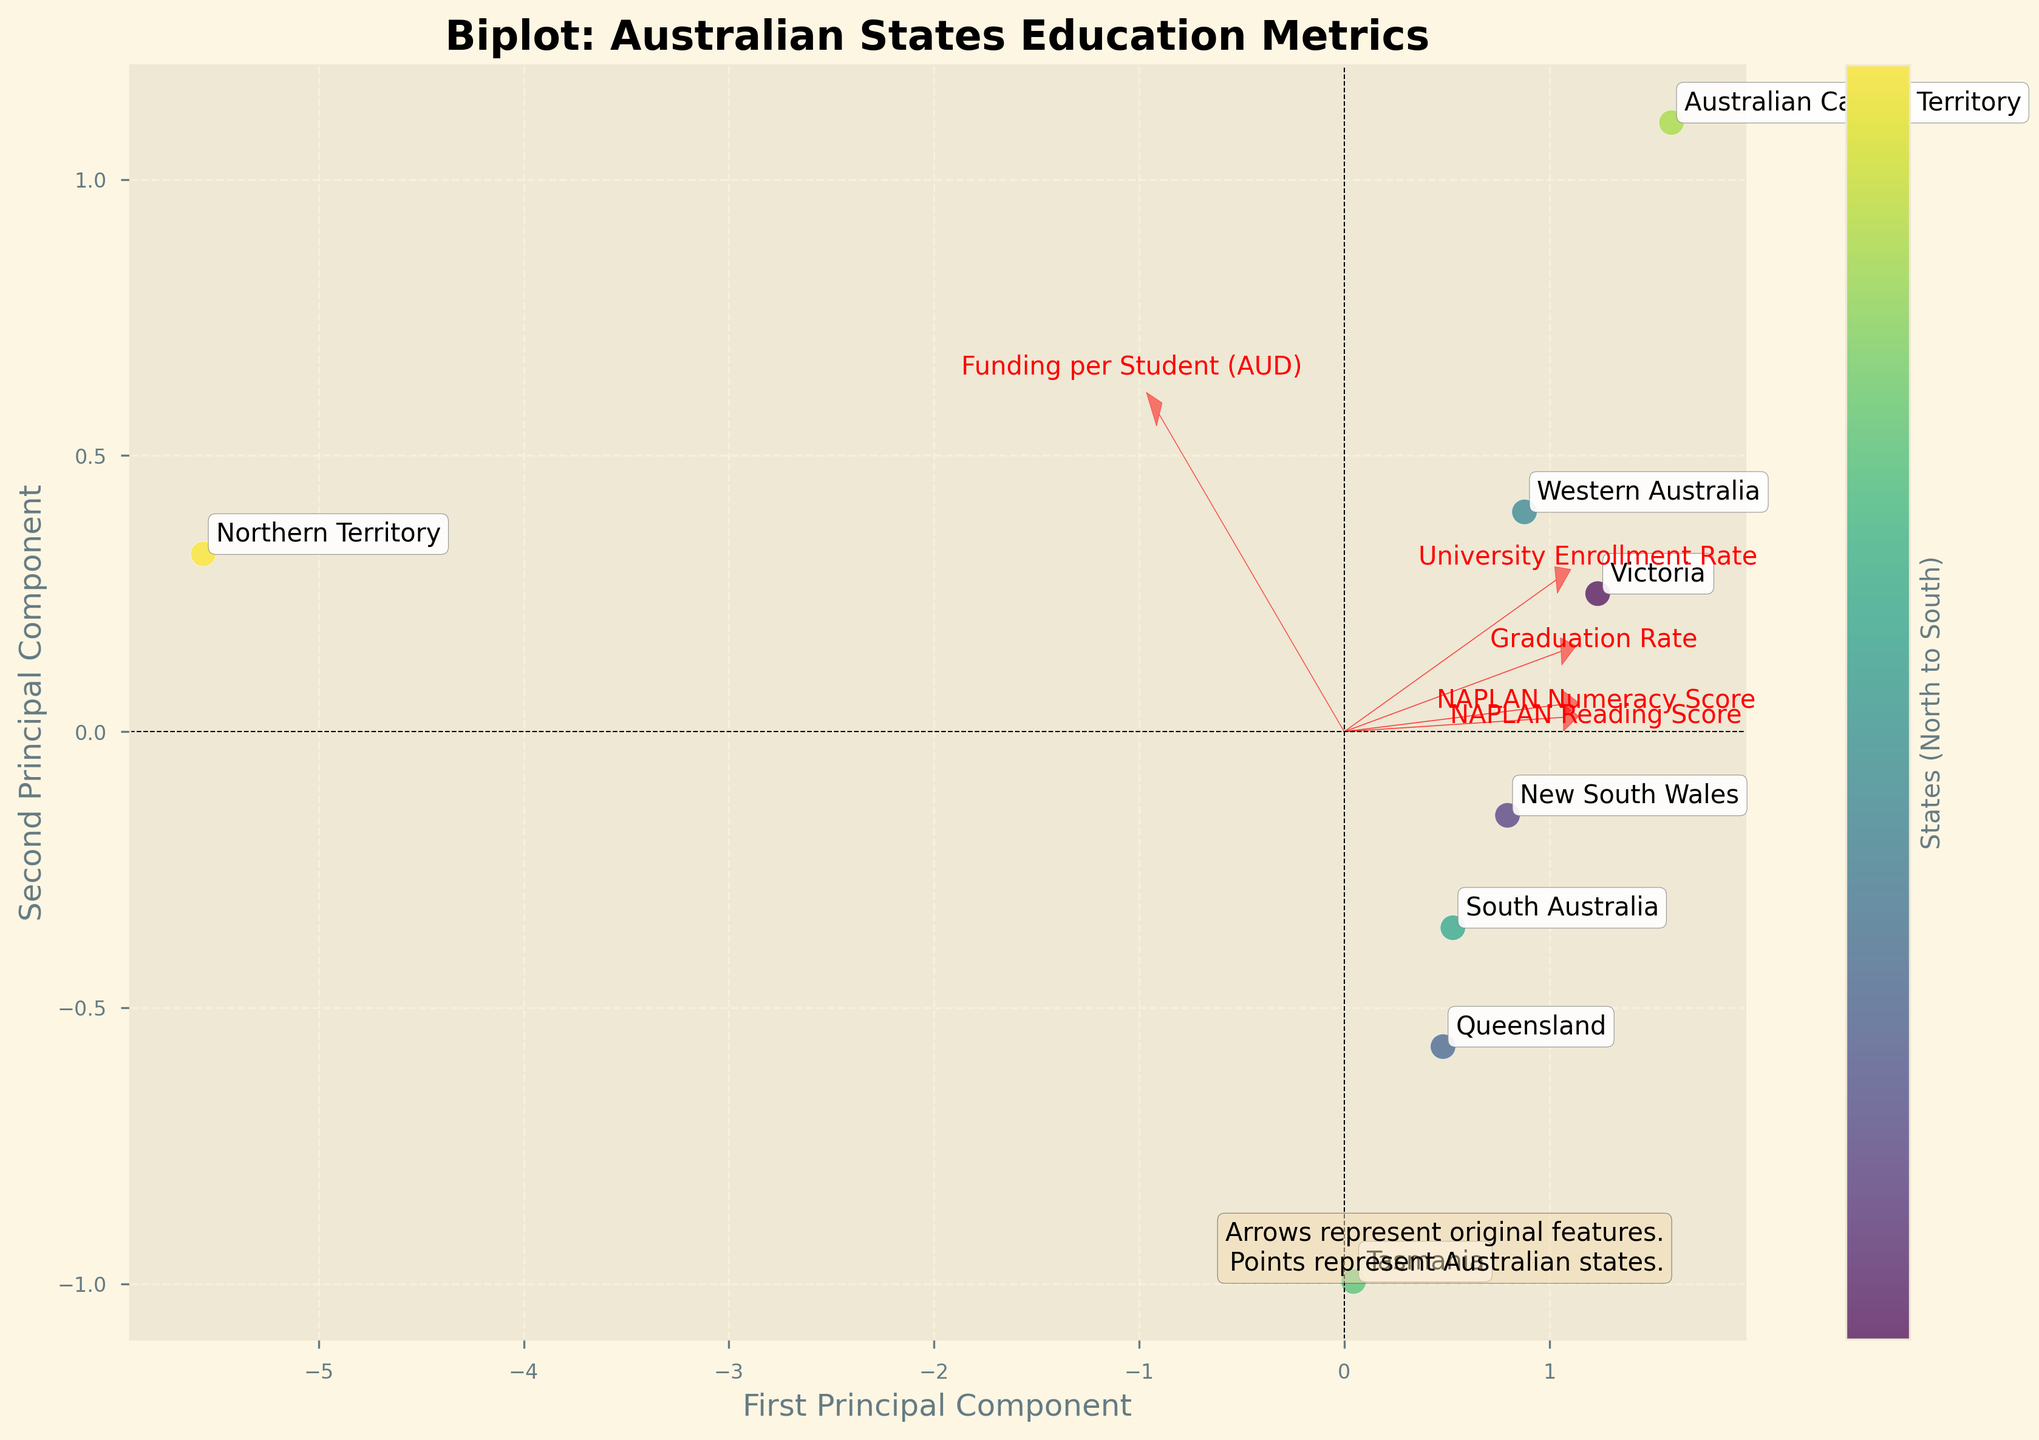What's the title of the figure? The title of the figure can be found at the top. It is typically a short description summing up the main topic illustrated. In this case, it should clearly state the focus of the plot.
Answer: Biplot: Australian States Education Metrics How many data points representing Australian states are plotted on the figure? The data points in the figure correspond to the number of Australian states. By counting the number of distinct points, which are likely to be annotated with state names, we get the number of states.
Answer: 8 Which state has the highest position on the second principal component? To determine this, observe the vertical axis (Second Principal Component) and identify which labeled point is highest. This indicates the state with the highest score on this component.
Answer: Australian Capital Territory Which feature has the longest arrow in the plot? The length of the arrows represents the magnitude of each feature's contribution to the principal components. The longest arrow implies the feature with the greatest influence.
Answer: Graduation Rate Which state has the lowest educational performance metrics on the biplot? To find this, look for the point that is furthest from the origin along the direction that aligns negatively with the main features' arrows. This state will be on the lower end of both principal components derived from standardized scores.
Answer: Northern Territory What effect does a high NAPLAN Reading Score have on a state's position on the biplot? Consider the direction of the arrow labeled "NAPLAN Reading Score." Points in the biplot positioned along the direction of this arrow are associated with higher values of NAPLAN Reading Scores.
Answer: Moves states rightward and slightly upward Which state is placed closest to the origin of the biplot? The origin is the point (0, 0). Identify the state whose labeled point is nearest to this center in both directions.
Answer: South Australia What can be inferred about states that are further away from the origin in terms of educational performance? Points further from the origin have more extreme values on the principal components. They likely have strong positive or negative deviations in at least some of the original metrics (funding, scores, rates).
Answer: They have more extreme educational performance metrics Do states with higher funding per student tend to have school metrics that cluster in the same part of the plot? Examine the direction and spread of the states relative to the "Funding per Student" arrow. Determine if these states with higher funding are grouped similarly.
Answer: Yes, generally upper-right How are university enrollment rates represented in the biplot and what does this indicate? Check the arrow labeled "University Enrollment Rate" and its direction. States aligned positively with this arrow have higher enrollment rates. Those not aligned have lower rates.
Answer: Represented as an increase in diagonal upward-right direction, indicating higher rates 